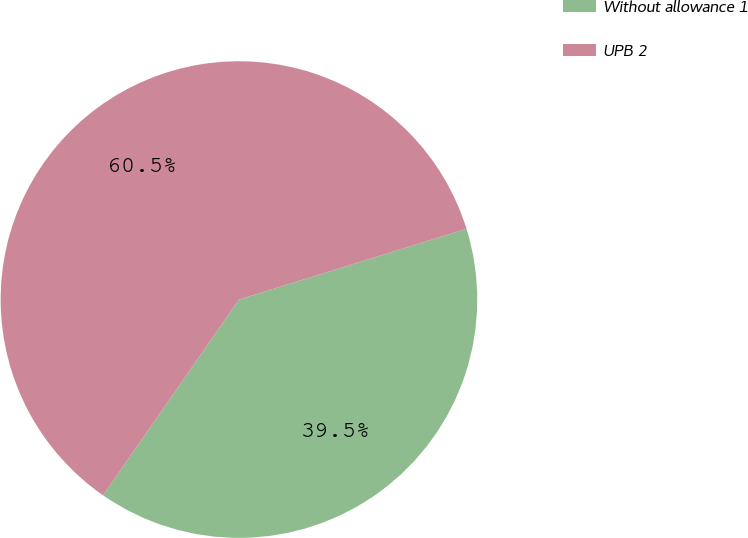Convert chart to OTSL. <chart><loc_0><loc_0><loc_500><loc_500><pie_chart><fcel>Without allowance 1<fcel>UPB 2<nl><fcel>39.46%<fcel>60.54%<nl></chart> 